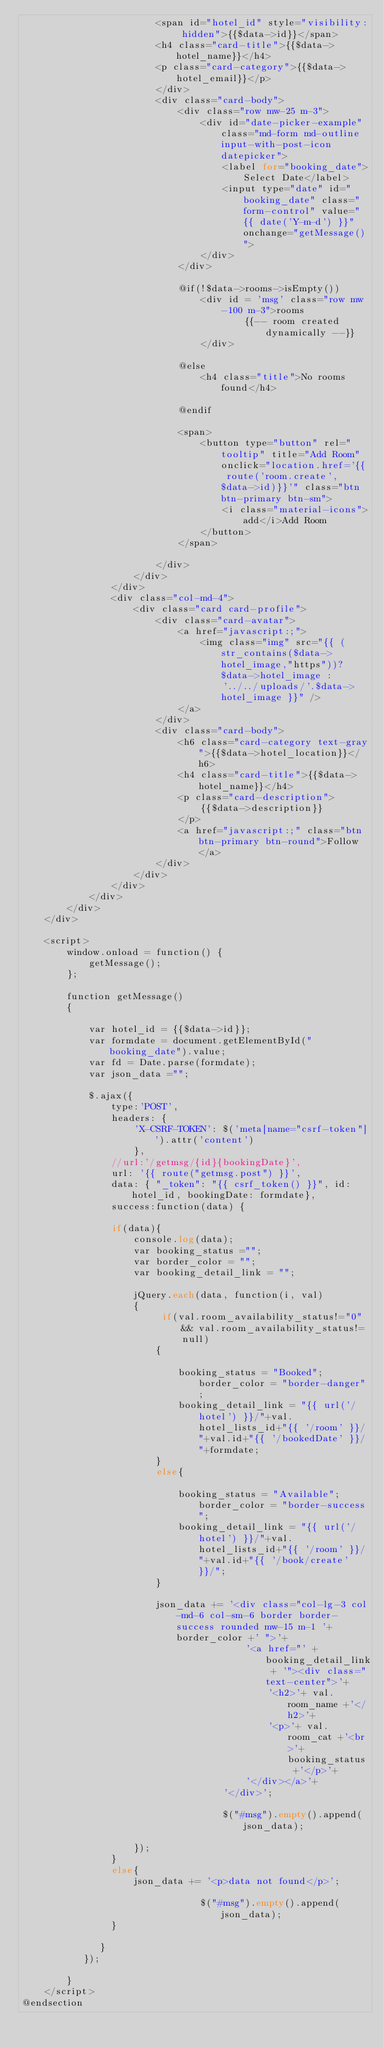Convert code to text. <code><loc_0><loc_0><loc_500><loc_500><_PHP_>                        <span id="hotel_id" style="visibility: hidden">{{$data->id}}</span>
                        <h4 class="card-title">{{$data->hotel_name}}</h4>
                        <p class="card-category">{{$data->hotel_email}}</p>
                        </div>
                        <div class="card-body">
                            <div class="row mw-25 m-3">
                                <div id="date-picker-example" class="md-form md-outline input-with-post-icon datepicker">
                                    <label for="booking_date">Select Date</label>
                                    <input type="date" id="booking_date" class="form-control" value="{{ date('Y-m-d') }}" onchange="getMessage()">
                                </div>
                            </div>

                            @if(!$data->rooms->isEmpty())
                                <div id = 'msg' class="row mw-100 m-3">rooms
                                        {{-- room created dynamically --}}
                                </div>

                            @else
                                <h4 class="title">No rooms found</h4>

                            @endif

                            <span>
                                <button type="button" rel="tooltip" title="Add Room" onclick="location.href='{{ route('room.create', $data->id)}}'" class="btn btn-primary btn-sm">
                                    <i class="material-icons">add</i>Add Room
                                </button>
                            </span>

                        </div>
                    </div>
                </div>
                <div class="col-md-4">
                    <div class="card card-profile">
                        <div class="card-avatar">
                            <a href="javascript:;">
                                <img class="img" src="{{ (str_contains($data->hotel_image,"https"))? $data->hotel_image : '../../uploads/'.$data->hotel_image }}" />
                            </a>
                        </div>
                        <div class="card-body">
                            <h6 class="card-category text-gray">{{$data->hotel_location}}</h6>
                            <h4 class="card-title">{{$data->hotel_name}}</h4>
                            <p class="card-description">
                                {{$data->description}}
                            </p>
                            <a href="javascript:;" class="btn btn-primary btn-round">Follow</a>
                        </div>
                    </div>
                </div>
            </div>
        </div>
    </div>

    <script>
        window.onload = function() {
            getMessage();
        };

        function getMessage()
        {

            var hotel_id = {{$data->id}};
            var formdate = document.getElementById("booking_date").value;
            var fd = Date.parse(formdate);
            var json_data ="";

            $.ajax({
                type:'POST',
                headers: {
                    'X-CSRF-TOKEN': $('meta[name="csrf-token"]').attr('content')
                    },
                //url:'/getmsg/{id}{bookingDate}',
                url: '{{ route("getmsg.post") }}',
                data: { "_token": "{{ csrf_token() }}", id: hotel_id, bookingDate: formdate},
                success:function(data) {

                if(data){
                    console.log(data);
                    var booking_status ="";
                    var border_color = "";
                    var booking_detail_link = "";

                    jQuery.each(data, function(i, val)
                    {
                         if(val.room_availability_status!="0" && val.room_availability_status!=null)
                        {

                            booking_status = "Booked"; border_color = "border-danger";
                            booking_detail_link = "{{ url('/hotel') }}/"+val.hotel_lists_id+"{{ '/room' }}/"+val.id+"{{ '/bookedDate' }}/"+formdate;
                        }
                        else{

                            booking_status = "Available"; border_color = "border-success";
                            booking_detail_link = "{{ url('/hotel') }}/"+val.hotel_lists_id+"{{ '/room' }}/"+val.id+"{{ '/book/create' }}/";
                        }

                        json_data += '<div class="col-lg-3 col-md-6 col-sm-6 border border-success rounded mw-15 m-1 '+ border_color +' ">'+
                                        '<a href="' + booking_detail_link + '"><div class="text-center">'+
                                            '<h2>'+ val.room_name +'</h2>'+
                                            '<p>'+ val.room_cat +'<br>'+ booking_status +'</p>'+
                                        '</div></a>'+
                                    '</div>';

                                    $("#msg").empty().append(json_data);

                    });
                }
                else{
                    json_data += '<p>data not found</p>';

                                $("#msg").empty().append(json_data);
                }

              }
           });

        }
    </script>
@endsection
</code> 